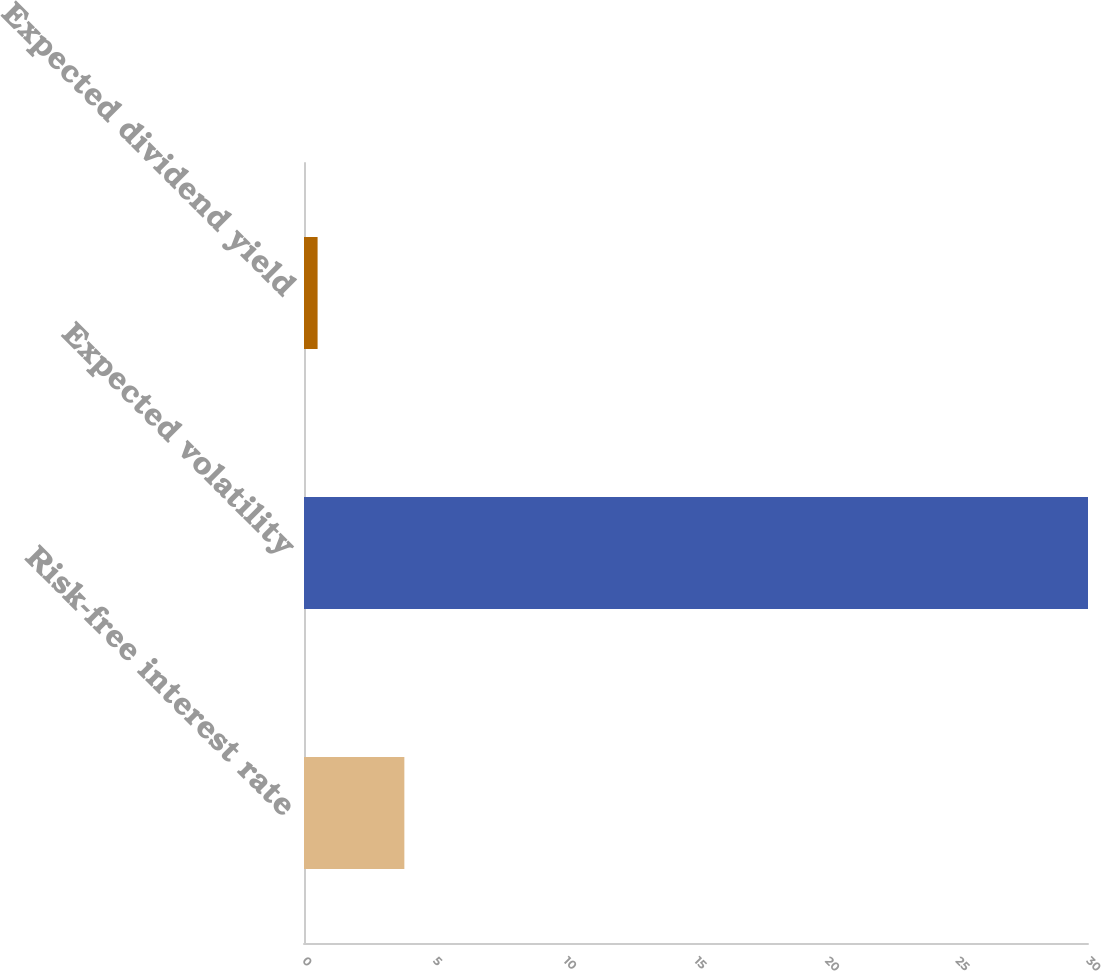<chart> <loc_0><loc_0><loc_500><loc_500><bar_chart><fcel>Risk-free interest rate<fcel>Expected volatility<fcel>Expected dividend yield<nl><fcel>3.84<fcel>30<fcel>0.52<nl></chart> 